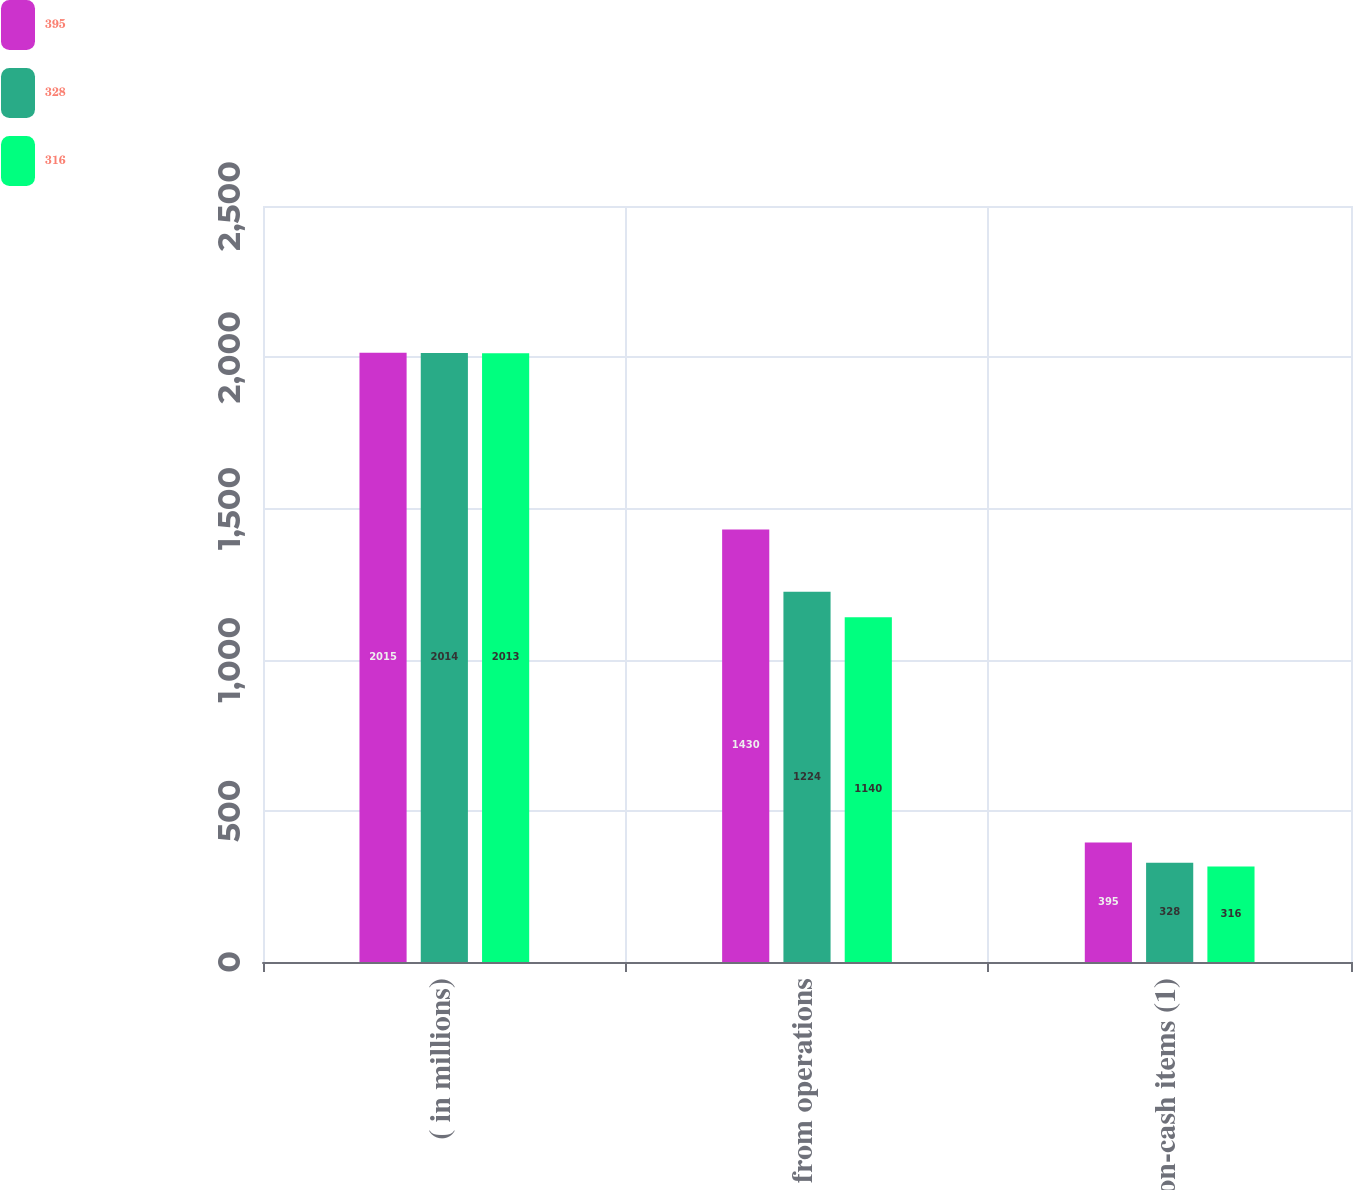<chart> <loc_0><loc_0><loc_500><loc_500><stacked_bar_chart><ecel><fcel>( in millions)<fcel>Cash from operations<fcel>Non-cash items (1)<nl><fcel>395<fcel>2015<fcel>1430<fcel>395<nl><fcel>328<fcel>2014<fcel>1224<fcel>328<nl><fcel>316<fcel>2013<fcel>1140<fcel>316<nl></chart> 